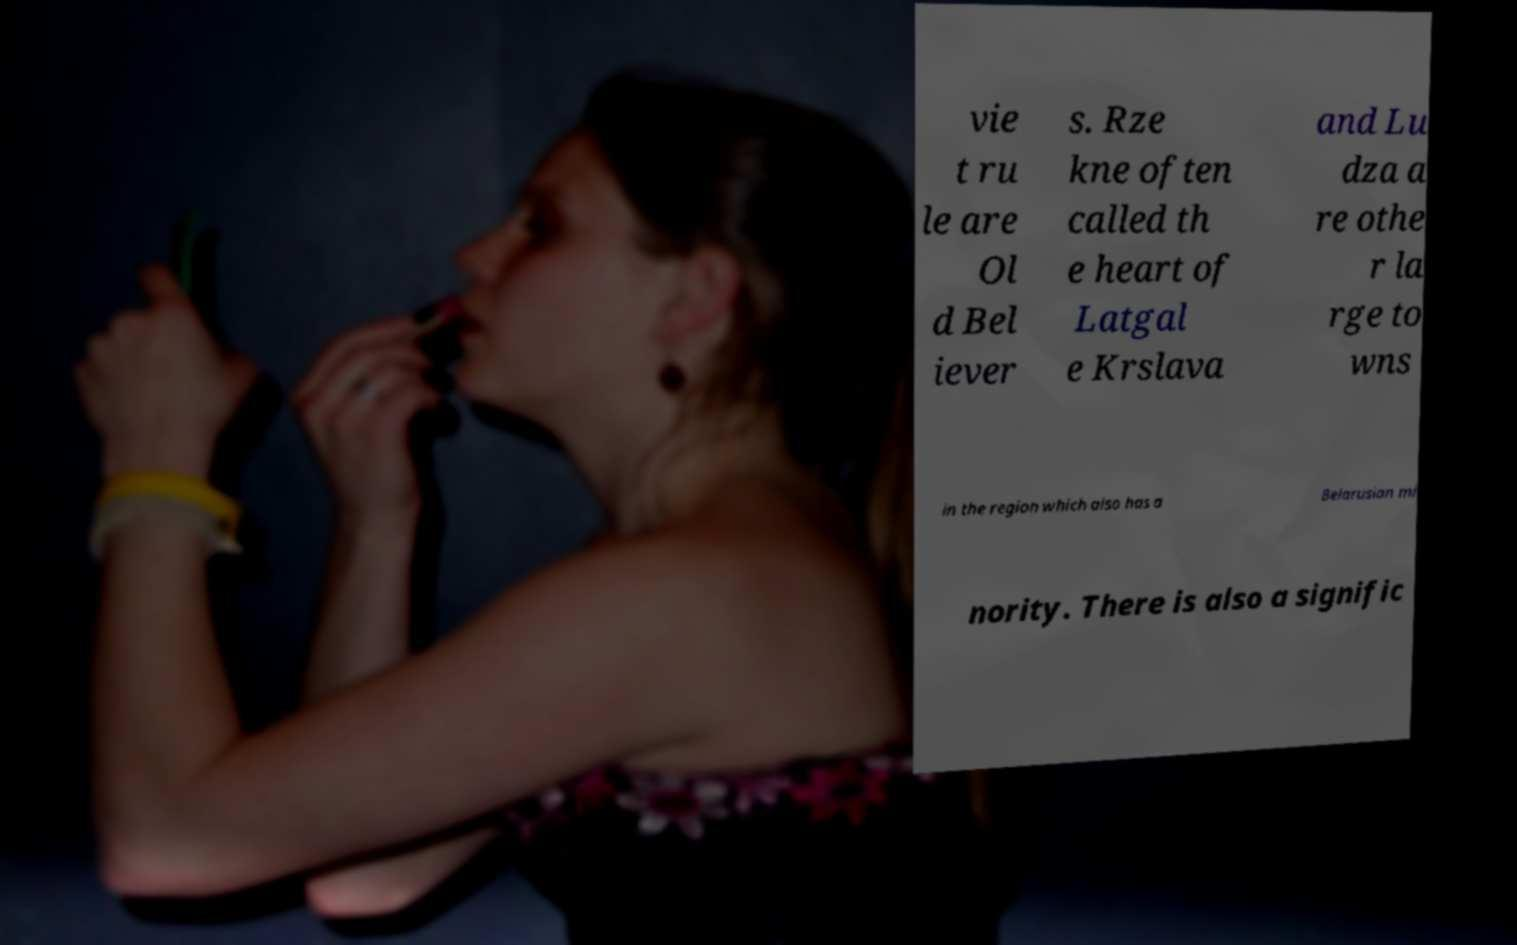For documentation purposes, I need the text within this image transcribed. Could you provide that? vie t ru le are Ol d Bel iever s. Rze kne often called th e heart of Latgal e Krslava and Lu dza a re othe r la rge to wns in the region which also has a Belarusian mi nority. There is also a signific 